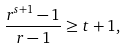<formula> <loc_0><loc_0><loc_500><loc_500>\frac { r ^ { s + 1 } - 1 } { r - 1 } \geq t + 1 ,</formula> 